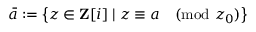Convert formula to latex. <formula><loc_0><loc_0><loc_500><loc_500>{ \bar { a } } \colon = \left \{ z \in Z [ i ] | z \equiv a { \pmod { z _ { 0 } } } \right \}</formula> 